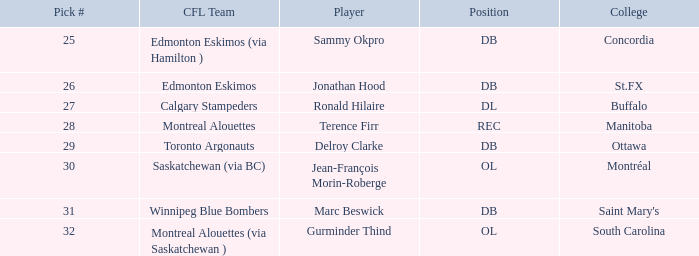Which College has a Pick # larger than 30, and a Position of ol? South Carolina. 